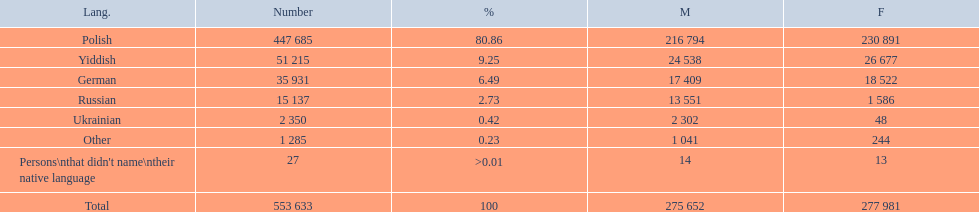How many speakers are represented in polish? 447 685. How many represented speakers are yiddish? 51 215. What is the total number of speakers? 553 633. 